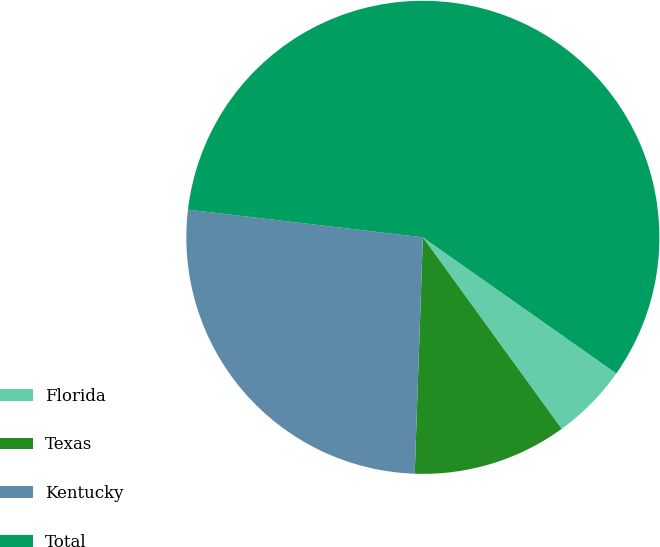Convert chart. <chart><loc_0><loc_0><loc_500><loc_500><pie_chart><fcel>Florida<fcel>Texas<fcel>Kentucky<fcel>Total<nl><fcel>5.26%<fcel>10.53%<fcel>26.32%<fcel>57.89%<nl></chart> 